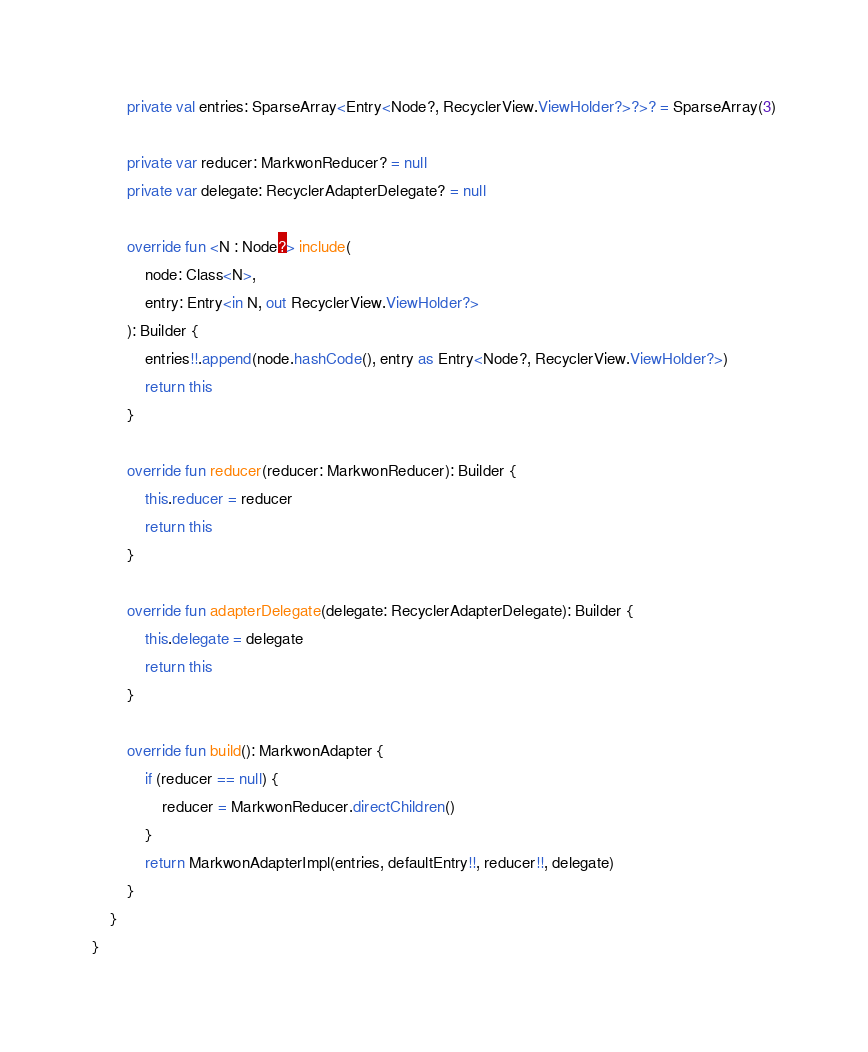Convert code to text. <code><loc_0><loc_0><loc_500><loc_500><_Kotlin_>
        private val entries: SparseArray<Entry<Node?, RecyclerView.ViewHolder?>?>? = SparseArray(3)

        private var reducer: MarkwonReducer? = null
        private var delegate: RecyclerAdapterDelegate? = null

        override fun <N : Node?> include(
            node: Class<N>,
            entry: Entry<in N, out RecyclerView.ViewHolder?>
        ): Builder {
            entries!!.append(node.hashCode(), entry as Entry<Node?, RecyclerView.ViewHolder?>)
            return this
        }

        override fun reducer(reducer: MarkwonReducer): Builder {
            this.reducer = reducer
            return this
        }

        override fun adapterDelegate(delegate: RecyclerAdapterDelegate): Builder {
            this.delegate = delegate
            return this
        }

        override fun build(): MarkwonAdapter {
            if (reducer == null) {
                reducer = MarkwonReducer.directChildren()
            }
            return MarkwonAdapterImpl(entries, defaultEntry!!, reducer!!, delegate)
        }
    }
}
</code> 